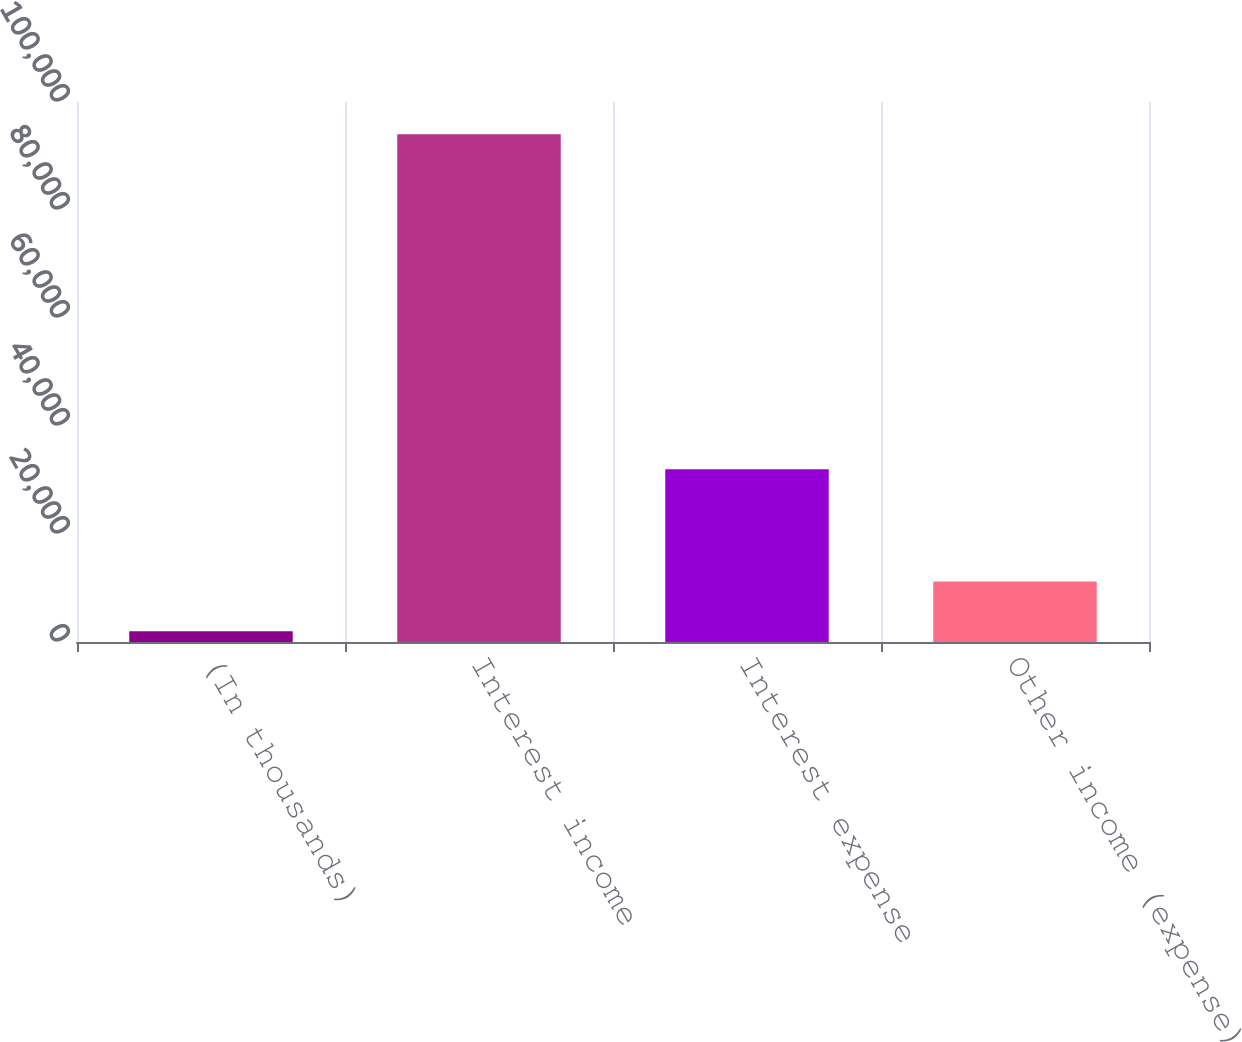Convert chart. <chart><loc_0><loc_0><loc_500><loc_500><bar_chart><fcel>(In thousands)<fcel>Interest income<fcel>Interest expense<fcel>Other income (expense) net<nl><fcel>2008<fcel>94022<fcel>32001<fcel>11209.4<nl></chart> 